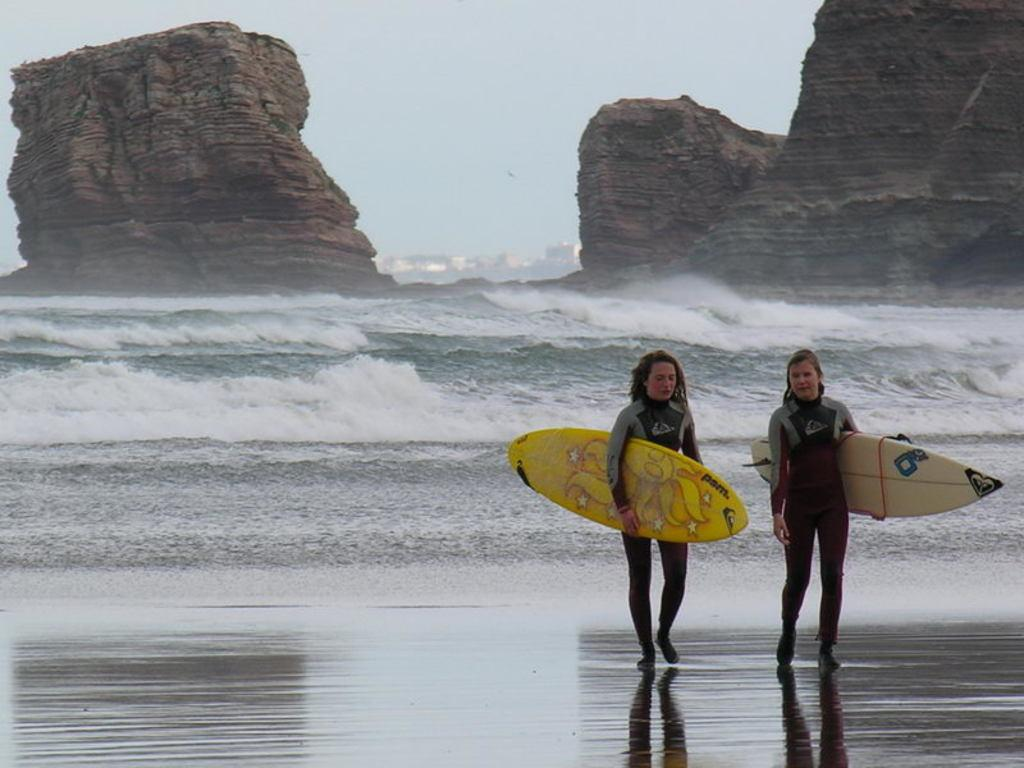What can be seen in the background of the image? There is a sky in the image. What is present in the foreground of the image? There is water in the image. What are the two people in the image doing? The two people are walking in the image. What are the two people holding while walking? The two people are holding yellow color surfboards. What type of boundary can be seen in the image? There is no boundary present in the image. What is the profit generated by the two people walking in the image? There is no mention of profit in the image, as it is not a business or commercial setting. 